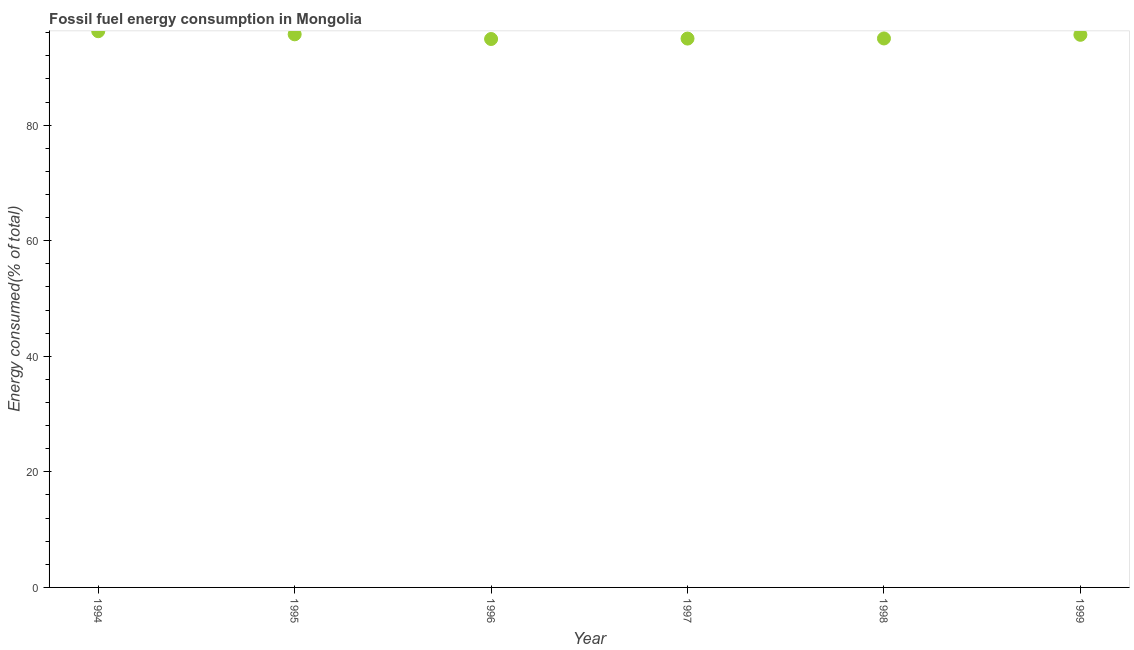What is the fossil fuel energy consumption in 1999?
Provide a short and direct response. 95.63. Across all years, what is the maximum fossil fuel energy consumption?
Keep it short and to the point. 96.25. Across all years, what is the minimum fossil fuel energy consumption?
Keep it short and to the point. 94.91. What is the sum of the fossil fuel energy consumption?
Offer a very short reply. 572.49. What is the difference between the fossil fuel energy consumption in 1995 and 1997?
Provide a short and direct response. 0.74. What is the average fossil fuel energy consumption per year?
Offer a terse response. 95.41. What is the median fossil fuel energy consumption?
Offer a terse response. 95.32. What is the ratio of the fossil fuel energy consumption in 1995 to that in 1996?
Give a very brief answer. 1.01. Is the fossil fuel energy consumption in 1997 less than that in 1999?
Offer a very short reply. Yes. Is the difference between the fossil fuel energy consumption in 1995 and 1999 greater than the difference between any two years?
Ensure brevity in your answer.  No. What is the difference between the highest and the second highest fossil fuel energy consumption?
Offer a very short reply. 0.54. Is the sum of the fossil fuel energy consumption in 1995 and 1998 greater than the maximum fossil fuel energy consumption across all years?
Offer a terse response. Yes. What is the difference between the highest and the lowest fossil fuel energy consumption?
Make the answer very short. 1.35. In how many years, is the fossil fuel energy consumption greater than the average fossil fuel energy consumption taken over all years?
Your answer should be very brief. 3. Does the fossil fuel energy consumption monotonically increase over the years?
Keep it short and to the point. No. How many dotlines are there?
Offer a very short reply. 1. Does the graph contain grids?
Give a very brief answer. No. What is the title of the graph?
Ensure brevity in your answer.  Fossil fuel energy consumption in Mongolia. What is the label or title of the Y-axis?
Offer a very short reply. Energy consumed(% of total). What is the Energy consumed(% of total) in 1994?
Give a very brief answer. 96.25. What is the Energy consumed(% of total) in 1995?
Your answer should be very brief. 95.72. What is the Energy consumed(% of total) in 1996?
Make the answer very short. 94.91. What is the Energy consumed(% of total) in 1997?
Ensure brevity in your answer.  94.98. What is the Energy consumed(% of total) in 1998?
Offer a very short reply. 95. What is the Energy consumed(% of total) in 1999?
Your answer should be compact. 95.63. What is the difference between the Energy consumed(% of total) in 1994 and 1995?
Your answer should be very brief. 0.54. What is the difference between the Energy consumed(% of total) in 1994 and 1996?
Your response must be concise. 1.35. What is the difference between the Energy consumed(% of total) in 1994 and 1997?
Your answer should be very brief. 1.27. What is the difference between the Energy consumed(% of total) in 1994 and 1998?
Your answer should be very brief. 1.25. What is the difference between the Energy consumed(% of total) in 1994 and 1999?
Provide a succinct answer. 0.62. What is the difference between the Energy consumed(% of total) in 1995 and 1996?
Your answer should be compact. 0.81. What is the difference between the Energy consumed(% of total) in 1995 and 1997?
Provide a short and direct response. 0.74. What is the difference between the Energy consumed(% of total) in 1995 and 1998?
Keep it short and to the point. 0.71. What is the difference between the Energy consumed(% of total) in 1995 and 1999?
Give a very brief answer. 0.08. What is the difference between the Energy consumed(% of total) in 1996 and 1997?
Ensure brevity in your answer.  -0.07. What is the difference between the Energy consumed(% of total) in 1996 and 1998?
Your answer should be compact. -0.1. What is the difference between the Energy consumed(% of total) in 1996 and 1999?
Provide a succinct answer. -0.73. What is the difference between the Energy consumed(% of total) in 1997 and 1998?
Offer a terse response. -0.02. What is the difference between the Energy consumed(% of total) in 1997 and 1999?
Offer a terse response. -0.65. What is the difference between the Energy consumed(% of total) in 1998 and 1999?
Ensure brevity in your answer.  -0.63. What is the ratio of the Energy consumed(% of total) in 1994 to that in 1997?
Provide a short and direct response. 1.01. What is the ratio of the Energy consumed(% of total) in 1995 to that in 1997?
Ensure brevity in your answer.  1.01. What is the ratio of the Energy consumed(% of total) in 1995 to that in 1998?
Offer a terse response. 1.01. What is the ratio of the Energy consumed(% of total) in 1996 to that in 1997?
Your answer should be very brief. 1. What is the ratio of the Energy consumed(% of total) in 1997 to that in 1998?
Your answer should be very brief. 1. What is the ratio of the Energy consumed(% of total) in 1997 to that in 1999?
Keep it short and to the point. 0.99. What is the ratio of the Energy consumed(% of total) in 1998 to that in 1999?
Ensure brevity in your answer.  0.99. 